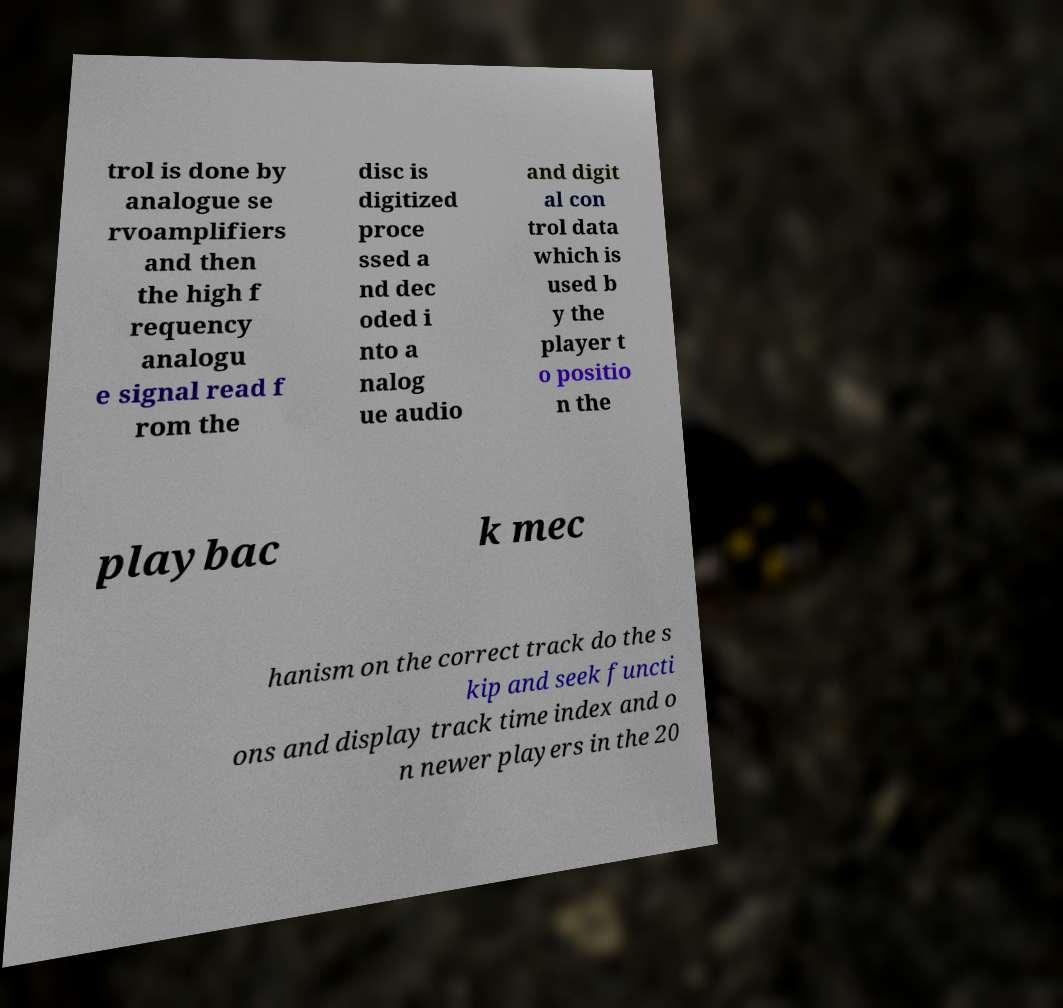Can you accurately transcribe the text from the provided image for me? trol is done by analogue se rvoamplifiers and then the high f requency analogu e signal read f rom the disc is digitized proce ssed a nd dec oded i nto a nalog ue audio and digit al con trol data which is used b y the player t o positio n the playbac k mec hanism on the correct track do the s kip and seek functi ons and display track time index and o n newer players in the 20 